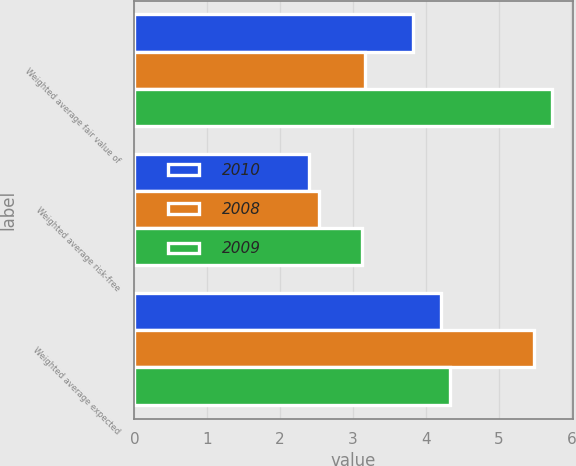<chart> <loc_0><loc_0><loc_500><loc_500><stacked_bar_chart><ecel><fcel>Weighted average fair value of<fcel>Weighted average risk-free<fcel>Weighted average expected<nl><fcel>2010<fcel>3.82<fcel>2.4<fcel>4.21<nl><fcel>2008<fcel>3.16<fcel>2.54<fcel>5.48<nl><fcel>2009<fcel>5.73<fcel>3.13<fcel>4.33<nl></chart> 